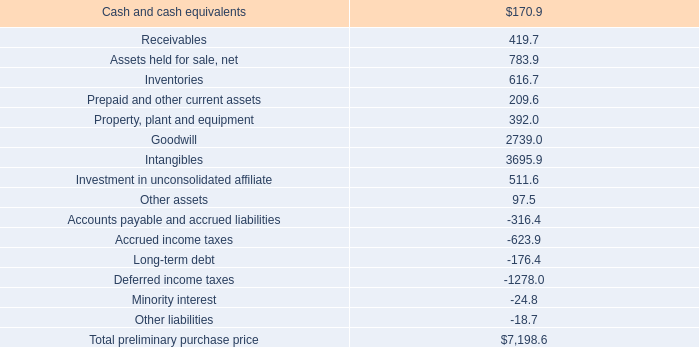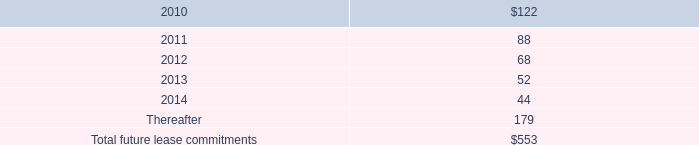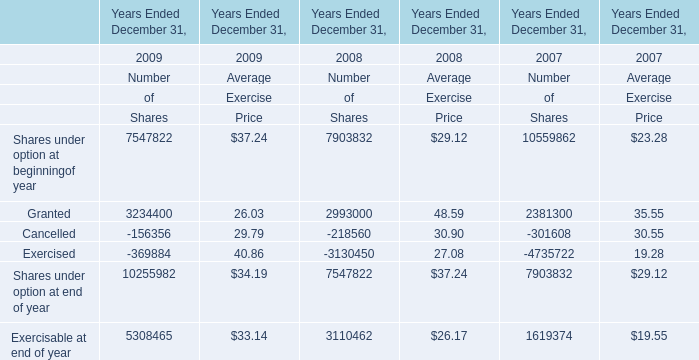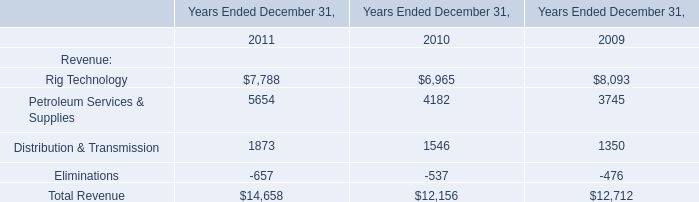What is the amount of Number of Shares that are under option at beginning of year 2009 Ended December 31? 
Answer: 7547822. 